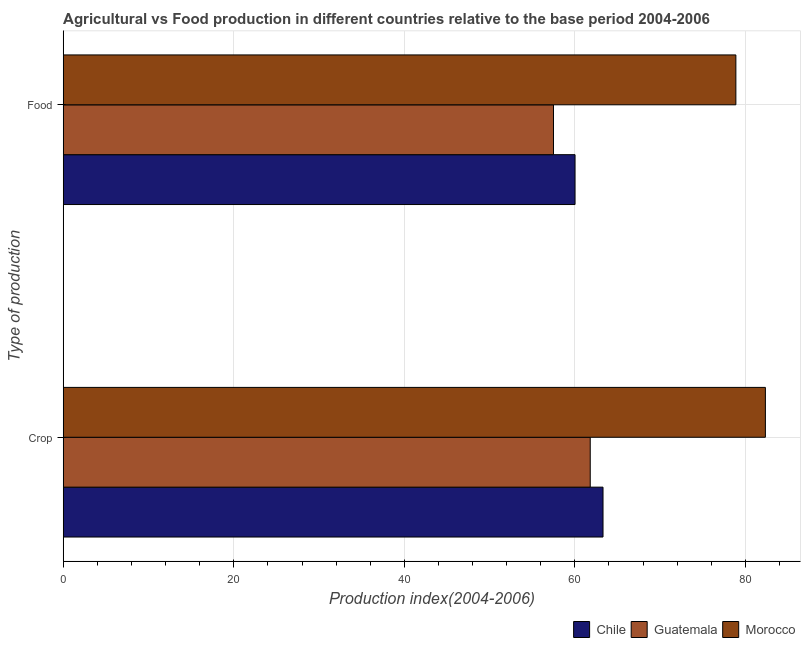Are the number of bars per tick equal to the number of legend labels?
Give a very brief answer. Yes. How many bars are there on the 2nd tick from the bottom?
Keep it short and to the point. 3. What is the label of the 1st group of bars from the top?
Provide a short and direct response. Food. What is the crop production index in Morocco?
Your answer should be compact. 82.34. Across all countries, what is the maximum food production index?
Make the answer very short. 78.88. Across all countries, what is the minimum crop production index?
Your response must be concise. 61.8. In which country was the food production index maximum?
Keep it short and to the point. Morocco. In which country was the food production index minimum?
Offer a terse response. Guatemala. What is the total crop production index in the graph?
Provide a short and direct response. 207.44. What is the difference between the crop production index in Morocco and that in Guatemala?
Your answer should be very brief. 20.54. What is the difference between the food production index in Chile and the crop production index in Guatemala?
Offer a terse response. -1.78. What is the average food production index per country?
Offer a terse response. 65.46. What is the difference between the food production index and crop production index in Chile?
Ensure brevity in your answer.  -3.28. What is the ratio of the food production index in Morocco to that in Guatemala?
Offer a terse response. 1.37. Is the food production index in Morocco less than that in Chile?
Your answer should be compact. No. In how many countries, is the food production index greater than the average food production index taken over all countries?
Offer a very short reply. 1. What does the 2nd bar from the top in Food represents?
Make the answer very short. Guatemala. What does the 3rd bar from the bottom in Crop represents?
Give a very brief answer. Morocco. What is the difference between two consecutive major ticks on the X-axis?
Offer a terse response. 20. Are the values on the major ticks of X-axis written in scientific E-notation?
Your answer should be very brief. No. Does the graph contain any zero values?
Make the answer very short. No. Does the graph contain grids?
Your answer should be very brief. Yes. What is the title of the graph?
Offer a very short reply. Agricultural vs Food production in different countries relative to the base period 2004-2006. Does "Lithuania" appear as one of the legend labels in the graph?
Offer a very short reply. No. What is the label or title of the X-axis?
Make the answer very short. Production index(2004-2006). What is the label or title of the Y-axis?
Offer a terse response. Type of production. What is the Production index(2004-2006) in Chile in Crop?
Your response must be concise. 63.3. What is the Production index(2004-2006) of Guatemala in Crop?
Your answer should be compact. 61.8. What is the Production index(2004-2006) in Morocco in Crop?
Your answer should be compact. 82.34. What is the Production index(2004-2006) of Chile in Food?
Make the answer very short. 60.02. What is the Production index(2004-2006) in Guatemala in Food?
Your answer should be compact. 57.49. What is the Production index(2004-2006) in Morocco in Food?
Make the answer very short. 78.88. Across all Type of production, what is the maximum Production index(2004-2006) of Chile?
Your answer should be very brief. 63.3. Across all Type of production, what is the maximum Production index(2004-2006) of Guatemala?
Your answer should be compact. 61.8. Across all Type of production, what is the maximum Production index(2004-2006) of Morocco?
Offer a terse response. 82.34. Across all Type of production, what is the minimum Production index(2004-2006) in Chile?
Provide a short and direct response. 60.02. Across all Type of production, what is the minimum Production index(2004-2006) of Guatemala?
Provide a succinct answer. 57.49. Across all Type of production, what is the minimum Production index(2004-2006) of Morocco?
Your answer should be very brief. 78.88. What is the total Production index(2004-2006) in Chile in the graph?
Your response must be concise. 123.32. What is the total Production index(2004-2006) in Guatemala in the graph?
Provide a succinct answer. 119.29. What is the total Production index(2004-2006) of Morocco in the graph?
Provide a succinct answer. 161.22. What is the difference between the Production index(2004-2006) of Chile in Crop and that in Food?
Your answer should be very brief. 3.28. What is the difference between the Production index(2004-2006) of Guatemala in Crop and that in Food?
Your answer should be very brief. 4.31. What is the difference between the Production index(2004-2006) in Morocco in Crop and that in Food?
Make the answer very short. 3.46. What is the difference between the Production index(2004-2006) of Chile in Crop and the Production index(2004-2006) of Guatemala in Food?
Provide a short and direct response. 5.81. What is the difference between the Production index(2004-2006) of Chile in Crop and the Production index(2004-2006) of Morocco in Food?
Keep it short and to the point. -15.58. What is the difference between the Production index(2004-2006) of Guatemala in Crop and the Production index(2004-2006) of Morocco in Food?
Give a very brief answer. -17.08. What is the average Production index(2004-2006) in Chile per Type of production?
Ensure brevity in your answer.  61.66. What is the average Production index(2004-2006) in Guatemala per Type of production?
Your answer should be compact. 59.65. What is the average Production index(2004-2006) of Morocco per Type of production?
Offer a very short reply. 80.61. What is the difference between the Production index(2004-2006) of Chile and Production index(2004-2006) of Guatemala in Crop?
Keep it short and to the point. 1.5. What is the difference between the Production index(2004-2006) in Chile and Production index(2004-2006) in Morocco in Crop?
Give a very brief answer. -19.04. What is the difference between the Production index(2004-2006) in Guatemala and Production index(2004-2006) in Morocco in Crop?
Keep it short and to the point. -20.54. What is the difference between the Production index(2004-2006) in Chile and Production index(2004-2006) in Guatemala in Food?
Offer a terse response. 2.53. What is the difference between the Production index(2004-2006) of Chile and Production index(2004-2006) of Morocco in Food?
Offer a very short reply. -18.86. What is the difference between the Production index(2004-2006) of Guatemala and Production index(2004-2006) of Morocco in Food?
Give a very brief answer. -21.39. What is the ratio of the Production index(2004-2006) of Chile in Crop to that in Food?
Your response must be concise. 1.05. What is the ratio of the Production index(2004-2006) of Guatemala in Crop to that in Food?
Offer a very short reply. 1.07. What is the ratio of the Production index(2004-2006) in Morocco in Crop to that in Food?
Your answer should be very brief. 1.04. What is the difference between the highest and the second highest Production index(2004-2006) of Chile?
Offer a very short reply. 3.28. What is the difference between the highest and the second highest Production index(2004-2006) of Guatemala?
Ensure brevity in your answer.  4.31. What is the difference between the highest and the second highest Production index(2004-2006) of Morocco?
Your answer should be very brief. 3.46. What is the difference between the highest and the lowest Production index(2004-2006) in Chile?
Ensure brevity in your answer.  3.28. What is the difference between the highest and the lowest Production index(2004-2006) of Guatemala?
Keep it short and to the point. 4.31. What is the difference between the highest and the lowest Production index(2004-2006) of Morocco?
Your answer should be very brief. 3.46. 